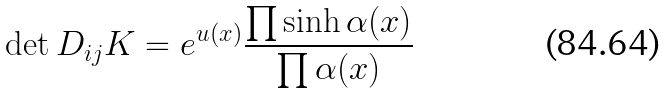Convert formula to latex. <formula><loc_0><loc_0><loc_500><loc_500>\det D _ { i j } { K } = e ^ { u ( x ) } \frac { \prod \sinh \alpha ( x ) } { \prod \alpha ( x ) }</formula> 